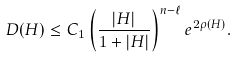Convert formula to latex. <formula><loc_0><loc_0><loc_500><loc_500>D ( H ) \leq C _ { 1 } \left ( \frac { | H | } { 1 + | H | } \right ) ^ { n - \ell } e ^ { 2 \rho ( H ) } .</formula> 